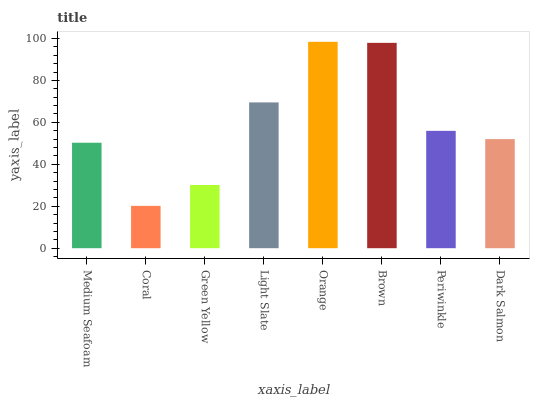Is Coral the minimum?
Answer yes or no. Yes. Is Orange the maximum?
Answer yes or no. Yes. Is Green Yellow the minimum?
Answer yes or no. No. Is Green Yellow the maximum?
Answer yes or no. No. Is Green Yellow greater than Coral?
Answer yes or no. Yes. Is Coral less than Green Yellow?
Answer yes or no. Yes. Is Coral greater than Green Yellow?
Answer yes or no. No. Is Green Yellow less than Coral?
Answer yes or no. No. Is Periwinkle the high median?
Answer yes or no. Yes. Is Dark Salmon the low median?
Answer yes or no. Yes. Is Light Slate the high median?
Answer yes or no. No. Is Medium Seafoam the low median?
Answer yes or no. No. 